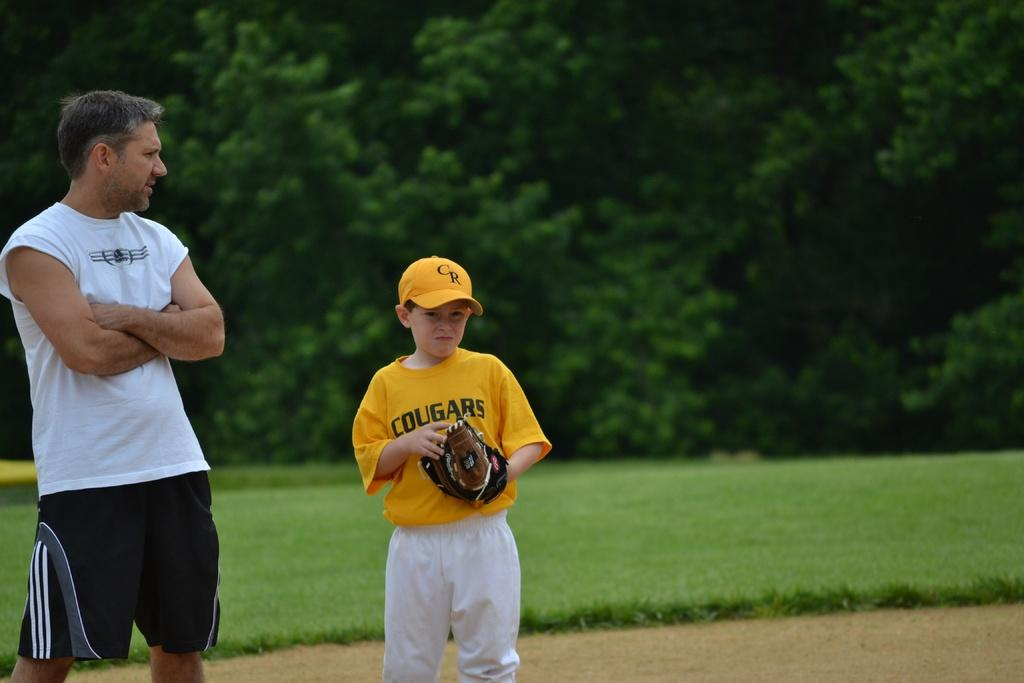<image>
Share a concise interpretation of the image provided. Boy wearing a yellow Cougars shirt standing next to a man. 